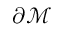<formula> <loc_0><loc_0><loc_500><loc_500>\partial \mathcal { M }</formula> 